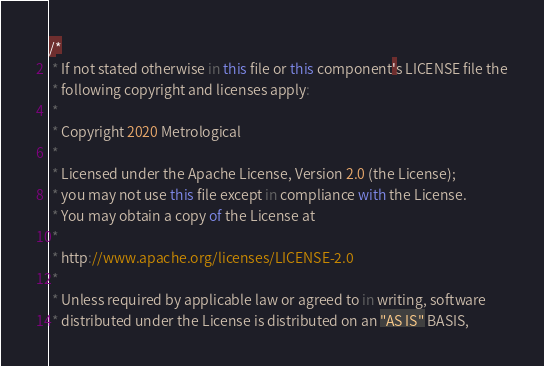<code> <loc_0><loc_0><loc_500><loc_500><_JavaScript_>/*
 * If not stated otherwise in this file or this component's LICENSE file the
 * following copyright and licenses apply:
 *
 * Copyright 2020 Metrological
 *
 * Licensed under the Apache License, Version 2.0 (the License);
 * you may not use this file except in compliance with the License.
 * You may obtain a copy of the License at
 *
 * http://www.apache.org/licenses/LICENSE-2.0
 *
 * Unless required by applicable law or agreed to in writing, software
 * distributed under the License is distributed on an "AS IS" BASIS,</code> 